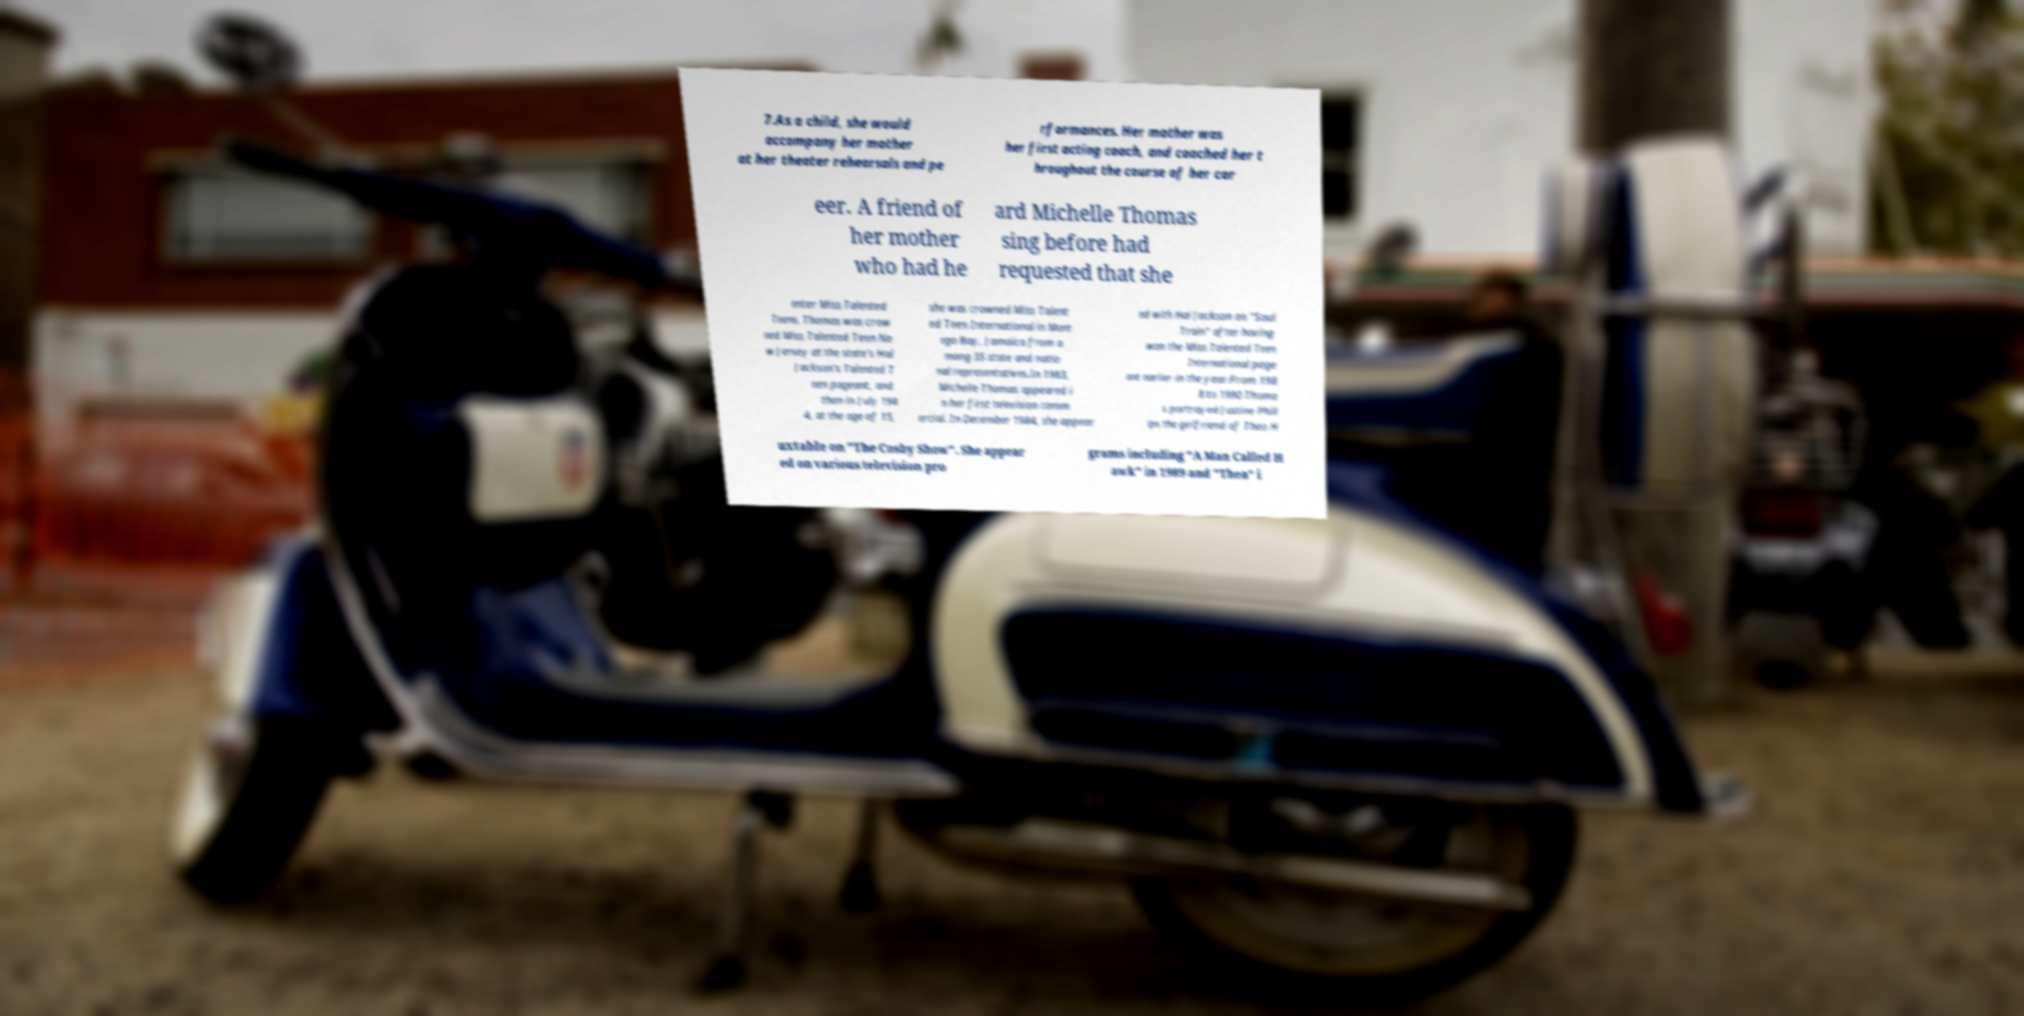Could you assist in decoding the text presented in this image and type it out clearly? 7.As a child, she would accompany her mother at her theater rehearsals and pe rformances. Her mother was her first acting coach, and coached her t hroughout the course of her car eer. A friend of her mother who had he ard Michelle Thomas sing before had requested that she enter Miss Talented Teens. Thomas was crow ned Miss Talented Teen Ne w Jersey at the state's Hal Jackson's Talented T een pageant, and then in July 198 4, at the age of 15, she was crowned Miss Talent ed Teen International in Mont ego Bay, Jamaica from a mong 35 state and natio nal representatives.In 1983, Michelle Thomas appeared i n her first television comm ercial. In December 1984, she appear ed with Hal Jackson on "Soul Train" after having won the Miss Talented Teen International page ant earlier in the year.From 198 8 to 1990 Thoma s portrayed Justine Phill ips the girlfriend of Theo H uxtable on "The Cosby Show". She appear ed on various television pro grams including "A Man Called H awk" in 1989 and "Thea" i 